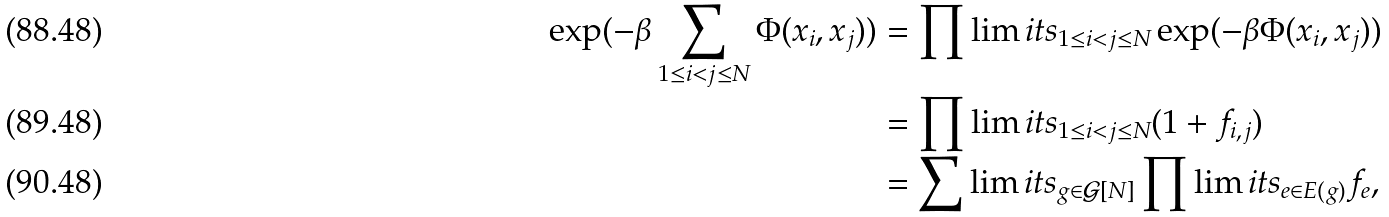Convert formula to latex. <formula><loc_0><loc_0><loc_500><loc_500>\exp ( - \beta \sum _ { 1 \leq i < j \leq N } \Phi ( x _ { i } , x _ { j } ) ) & = \prod \lim i t s _ { 1 \leq i < j \leq N } \exp ( - \beta \Phi ( x _ { i } , x _ { j } ) ) \\ & = \prod \lim i t s _ { 1 \leq i < j \leq N } ( 1 + f _ { i , j } ) \\ & = \sum \lim i t s _ { g \in \mathcal { G } [ N ] } \prod \lim i t s _ { e \in E ( g ) } f _ { e } ,</formula> 